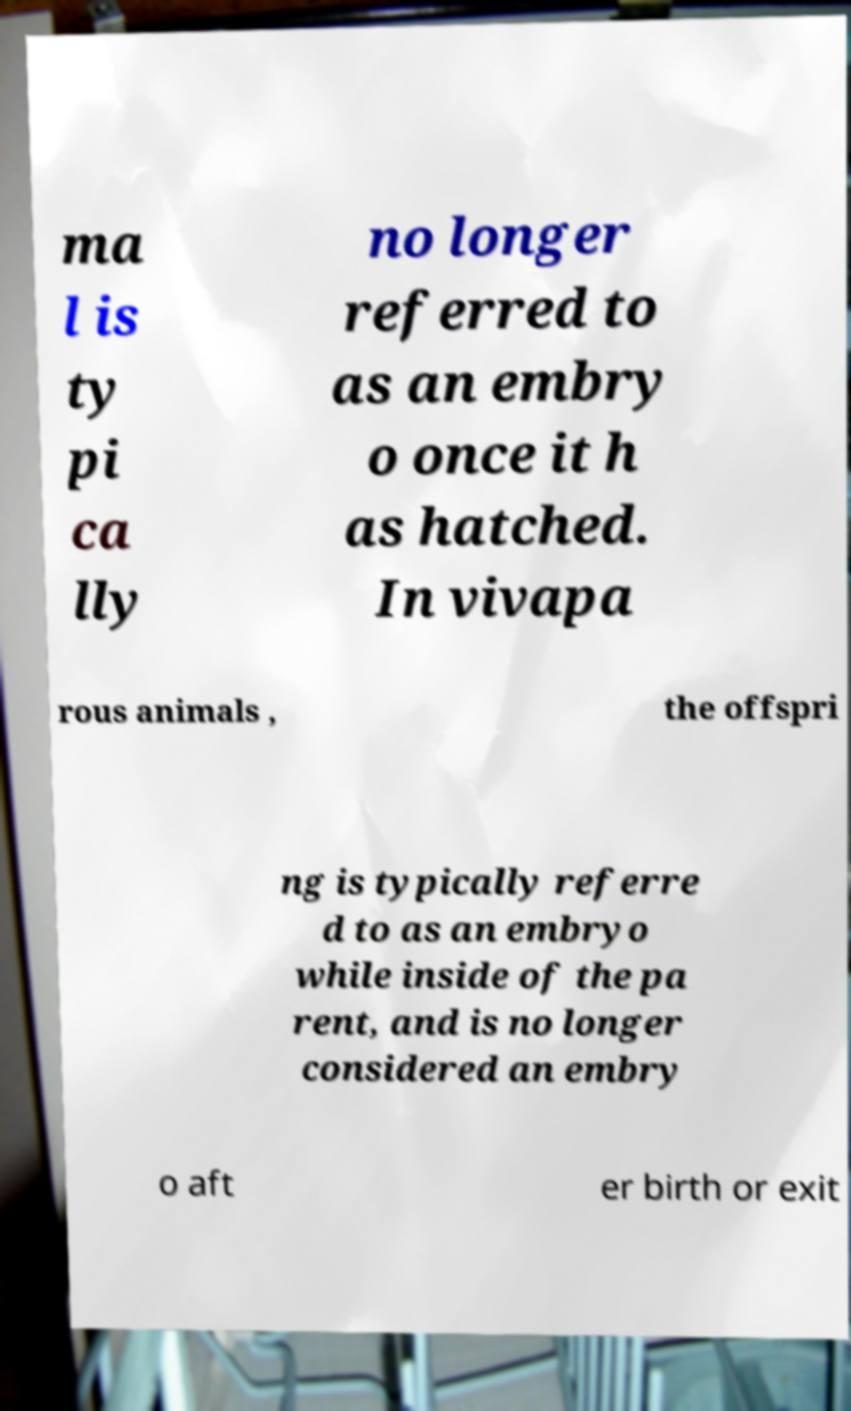Can you read and provide the text displayed in the image?This photo seems to have some interesting text. Can you extract and type it out for me? ma l is ty pi ca lly no longer referred to as an embry o once it h as hatched. In vivapa rous animals , the offspri ng is typically referre d to as an embryo while inside of the pa rent, and is no longer considered an embry o aft er birth or exit 